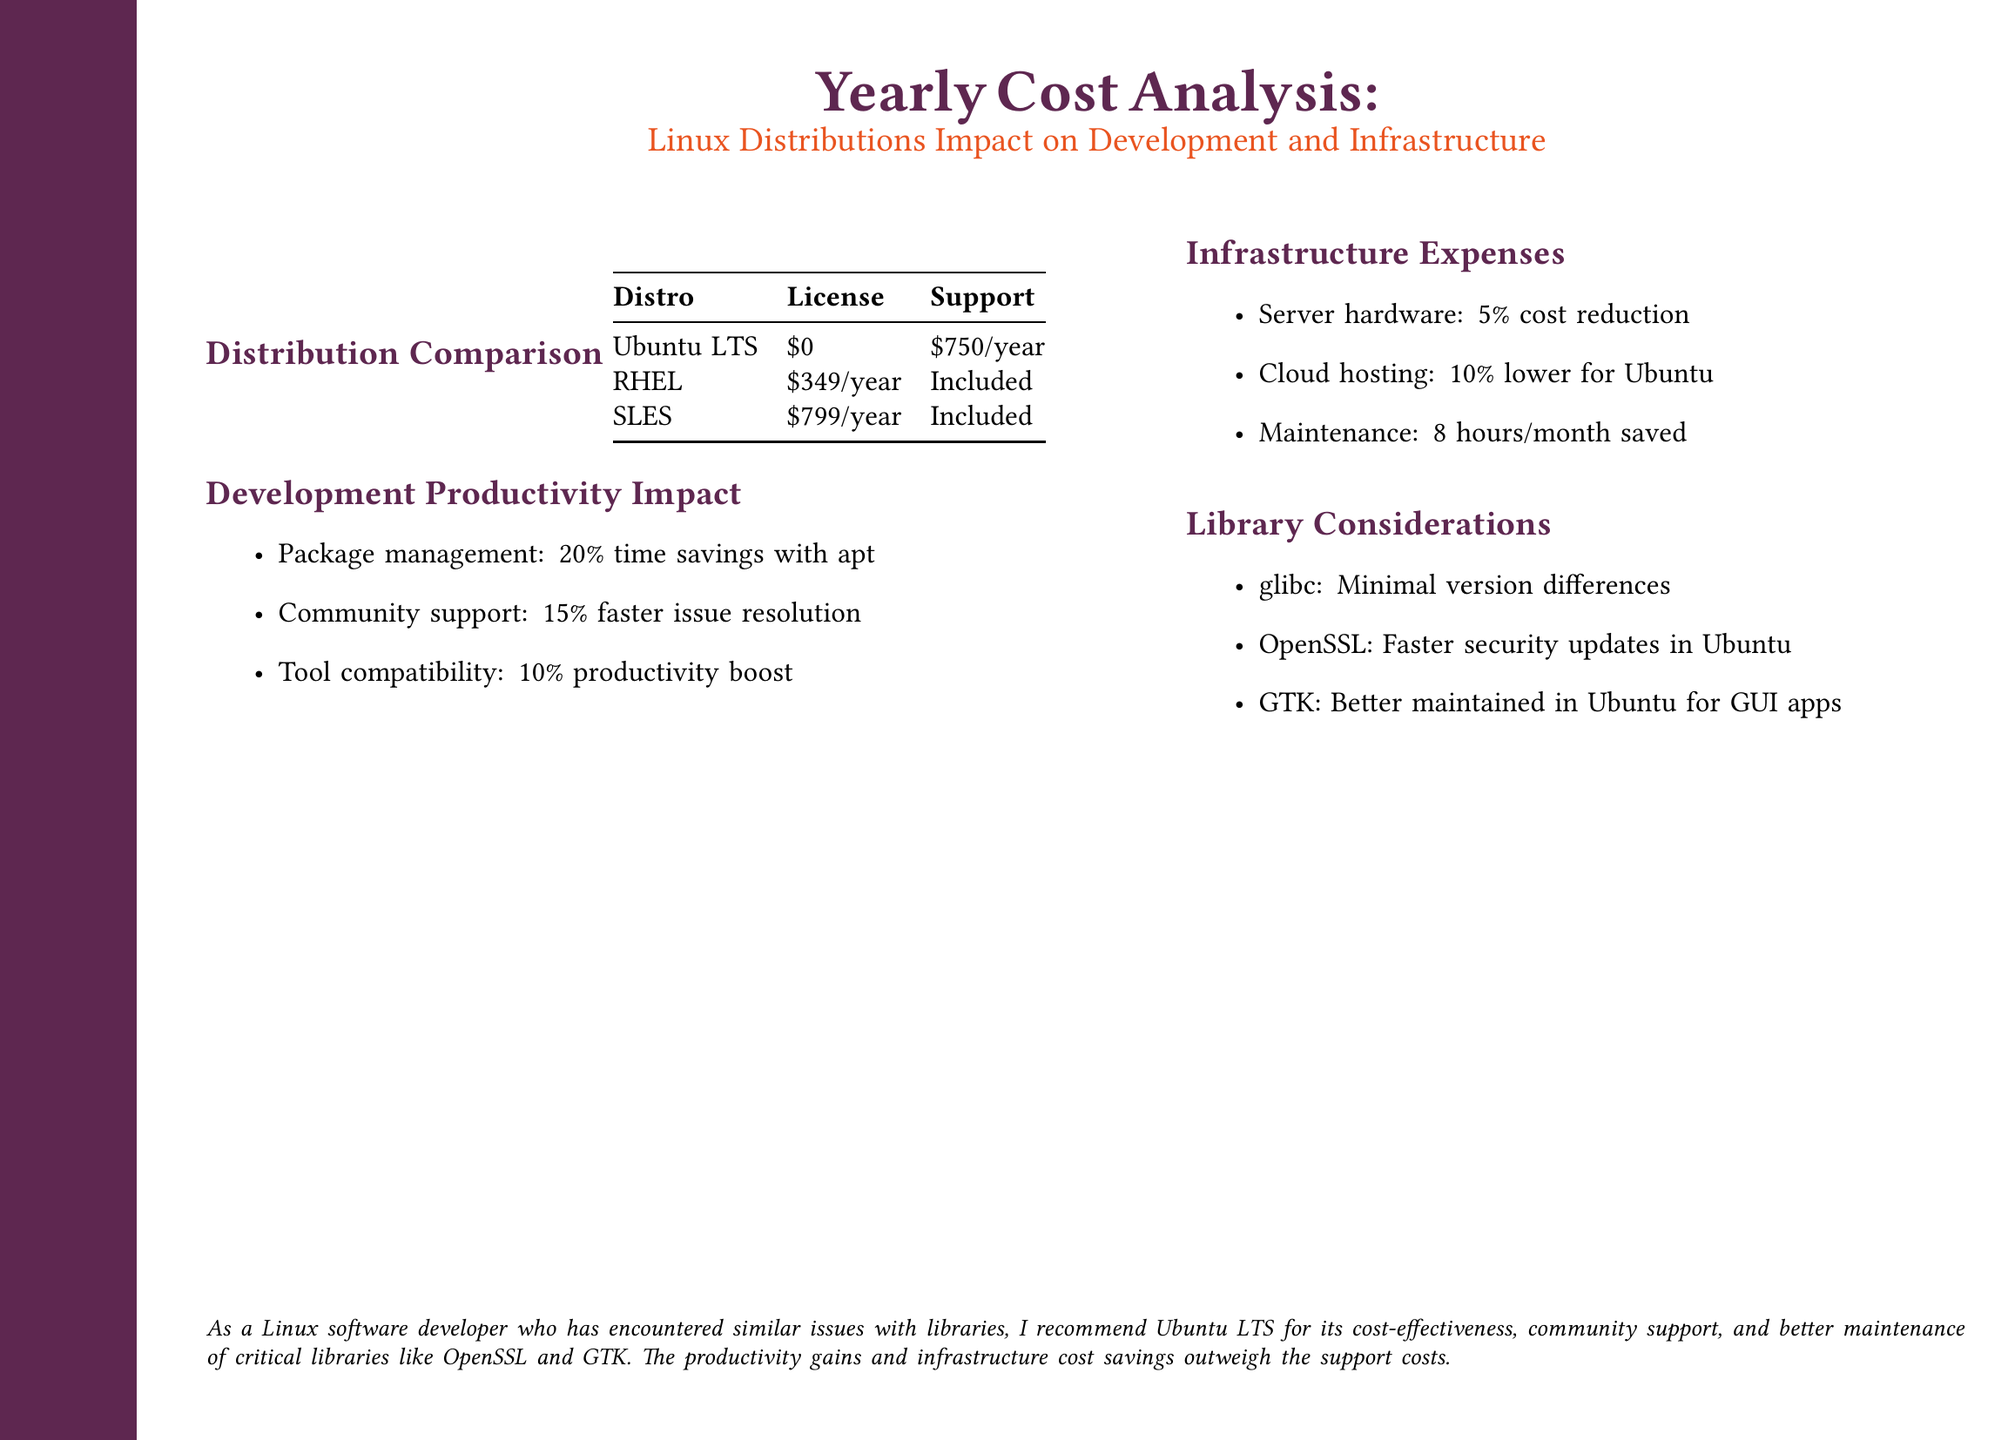What is the license cost for RHEL? The license cost for RHEL is explicitly stated in the table as \$349/year.
Answer: \$349/year What is the yearly support cost for Ubuntu LTS? The yearly support cost for Ubuntu LTS is given in the distribution comparison table as \$750/year.
Answer: \$750/year What percentage time savings does apt provide in package management? The document states that package management with apt yields a 20% time savings.
Answer: 20% Which distribution has faster security updates for OpenSSL? The document mentions that Ubuntu has faster security updates for OpenSSL.
Answer: Ubuntu How many hours per month are saved in maintenance for infrastructure expenses? The document specifies that 8 hours/month are saved in maintenance expenses.
Answer: 8 hours/month Which Linux distribution is recommended for cost-effectiveness and better maintenance? The recommendation in the document points to Ubuntu LTS for its cost-effectiveness and maintenance.
Answer: Ubuntu LTS What impact does cloud hosting have on costs for Ubuntu compared to other distributions? The document indicates that cloud hosting is 10% lower for Ubuntu compared to other distributions.
Answer: 10% lower What library shows better maintenance in Ubuntu for GUI applications? The document states that GTK is better maintained in Ubuntu for GUI applications.
Answer: GTK What is the overall support cost for SLES? The support cost for SLES is indicated in the table as \$799/year.
Answer: \$799/year 